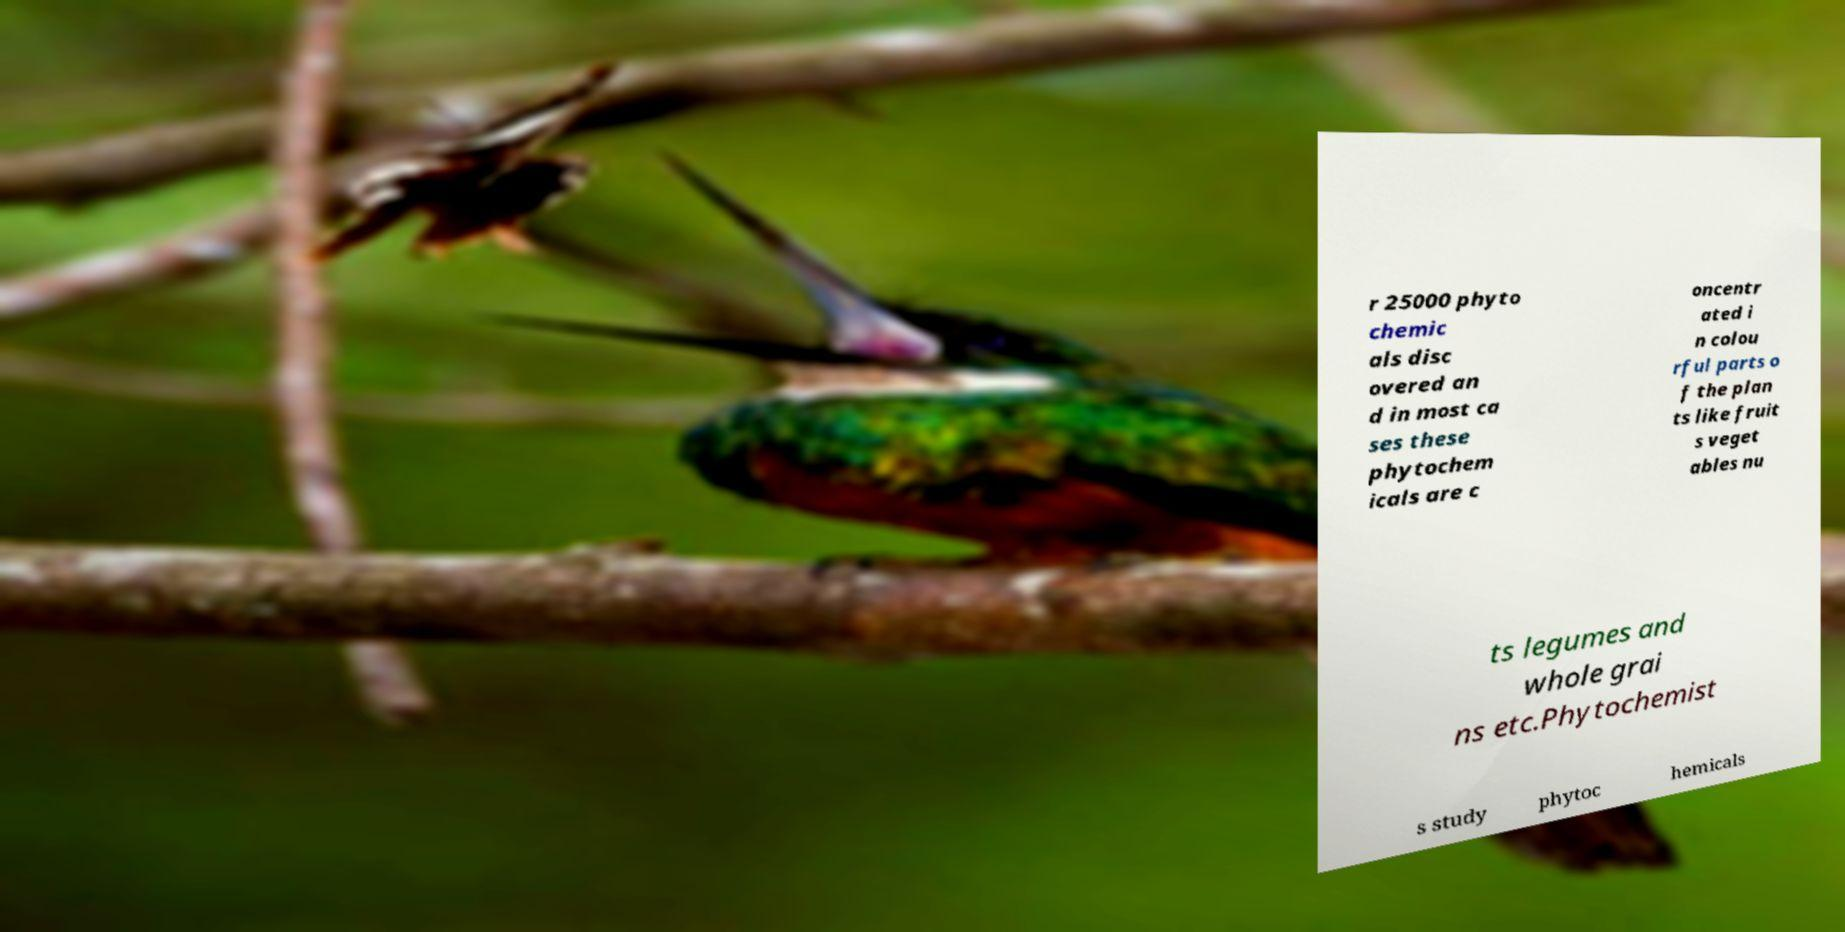Can you read and provide the text displayed in the image?This photo seems to have some interesting text. Can you extract and type it out for me? r 25000 phyto chemic als disc overed an d in most ca ses these phytochem icals are c oncentr ated i n colou rful parts o f the plan ts like fruit s veget ables nu ts legumes and whole grai ns etc.Phytochemist s study phytoc hemicals 